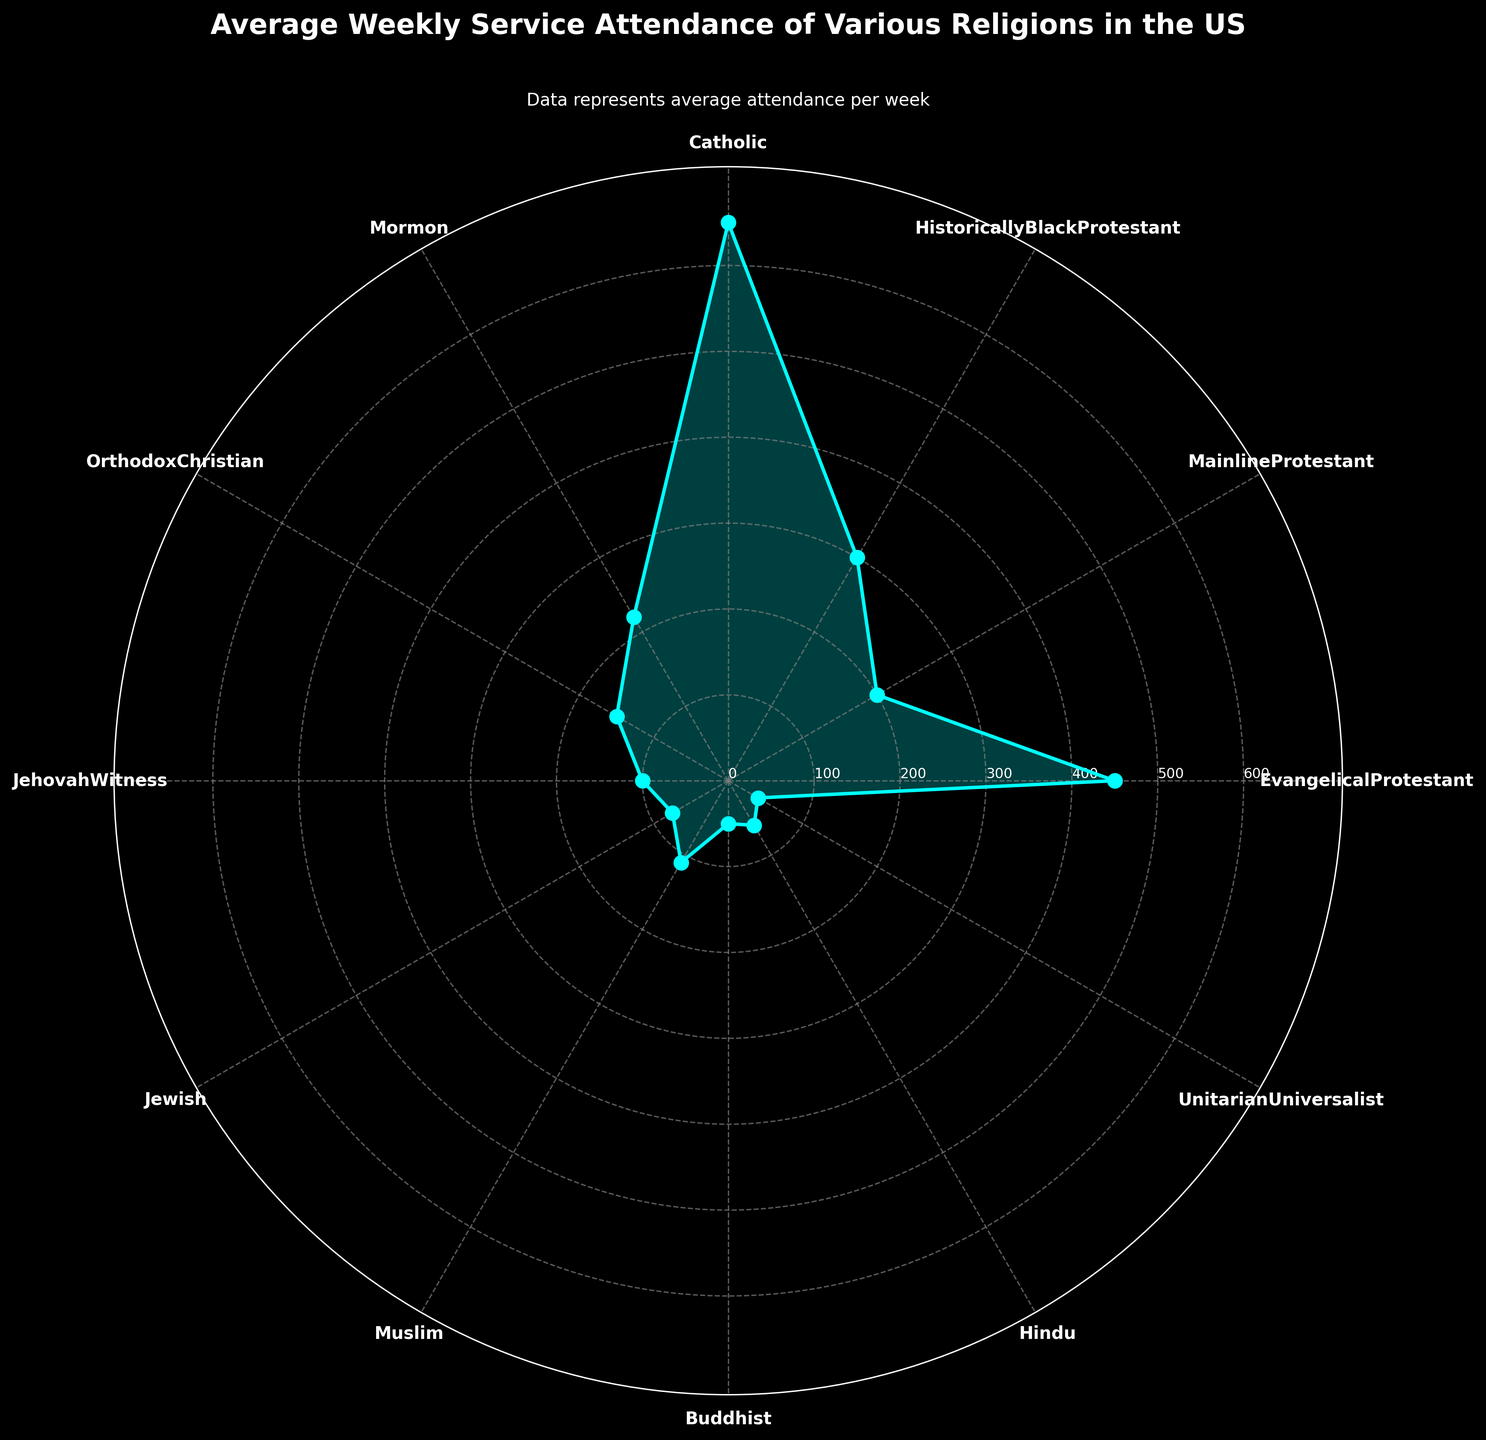What's the title of the chart? The title is the text displayed at the top of the chart. In this case, it describes the content of the chart.
Answer: Average Weekly Service Attendance of Various Religions in the US Which religion has the highest average weekly attendance? To determine this, look for the highest value on the chart, which is indicated at the peak of a segment on the polar plot. In this case, the religion at the highest point is labeled.
Answer: Catholic What is the average weekly attendance of Mormons? Find the segment labeled 'Mormon' and note the value on the radial axis that corresponds to the end of this segment.
Answer: 220 Compare the average weekly attendance of Evangelical Protestants to Mainline Protestants. Who attends more frequently? Locate both the 'Evangelical Protestant' and 'Mainline Protestant' segments on the plot. Compare their radial lengths to see which extends further from the center.
Answer: Evangelical Protestants What is the difference in average weekly attendance between Historically Black Protestants and Jehovah’s Witnesses? Find the radial values for 'Historically Black Protestant' and 'Jehovah Witness' segments. Subtract the smaller value from the larger one.
Answer: 200 Which religion has the lowest average weekly attendance and what is the value? Look for the segment that is closest to the center of the polar plot. This indicates the lowest attendance. Check the corresponding label and value.
Answer: Unitarian Universalist, 40 Identify two religions with similar average weekly attendance and describe their values. Locate segments that are approximately the same distance from the center. Look for labels and note their corresponding radial values. For instance, 'Hindu' and 'Muslim' segments are close to each other.
Answer: Hindu: 60, Muslim: 110 What visual elements are used to represent the data on the chart? The chart uses a radial plot with segments representing each religion. Points are connected by lines, filled with a translucent color to highlight the area, and labeled accordingly.
Answer: Radial plot, segments, labels, connected points, and filled areas Estimate the cumulative average weekly attendance of all religions combined. Sum the average weekly attendance values of all the religions. Adding them together yields an approximate total.
Answer: 2405 